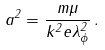Convert formula to latex. <formula><loc_0><loc_0><loc_500><loc_500>a ^ { 2 } = \frac { m \mu } { k ^ { 2 } e \lambda _ { \phi } ^ { 2 } } \, .</formula> 